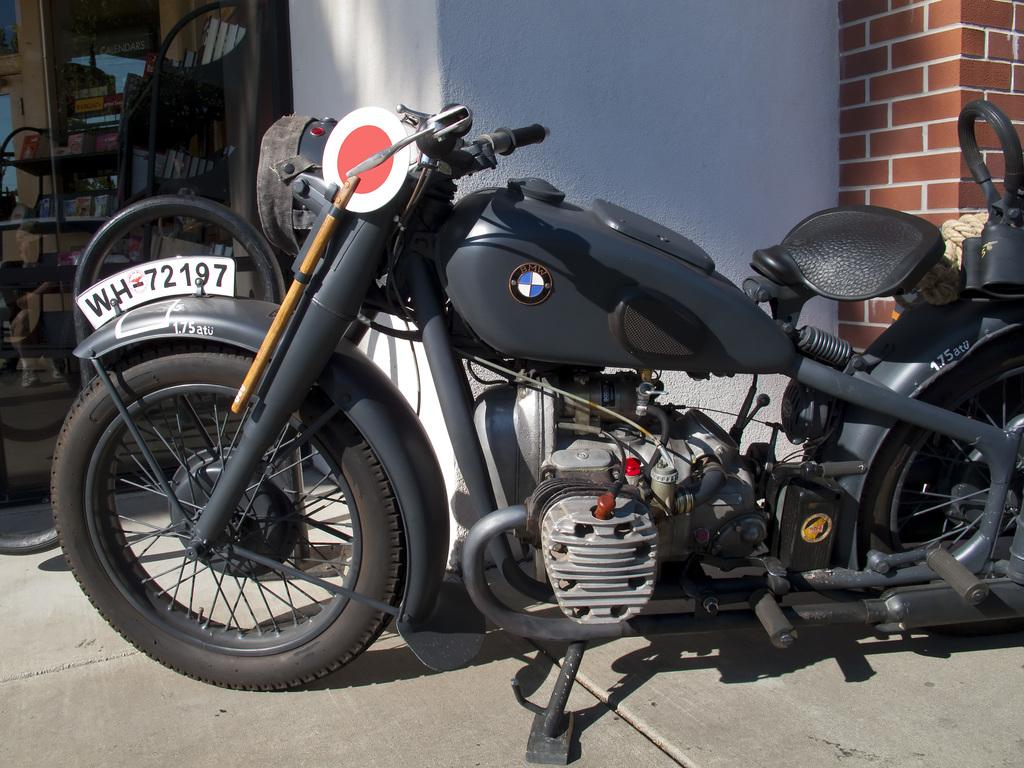What is the main subject of the image? The main subject of the image is a motorbike. How is the motorbike positioned in the image? The motorbike is placed on the ground. What can be seen attached to the backside of the motorbike? There are objects placed in the racks on the backside of the motorbike. What additional detail can be observed in the image? There is a rope visible in the image. What is visible in the background of the image? There is a wall in the background of the image. What type of brush is being used to paint the canvas in the image? There is no brush or canvas present in the image; it features a motorbike with objects in the racks and a rope. 